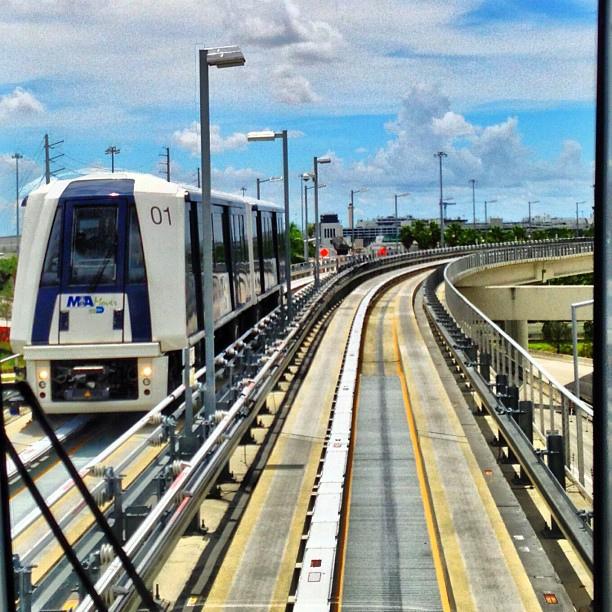How many train tracks are there?
Concise answer only. 2. What number is on the tram?
Keep it brief. 01. Is the train leaving the station?
Give a very brief answer. Yes. 